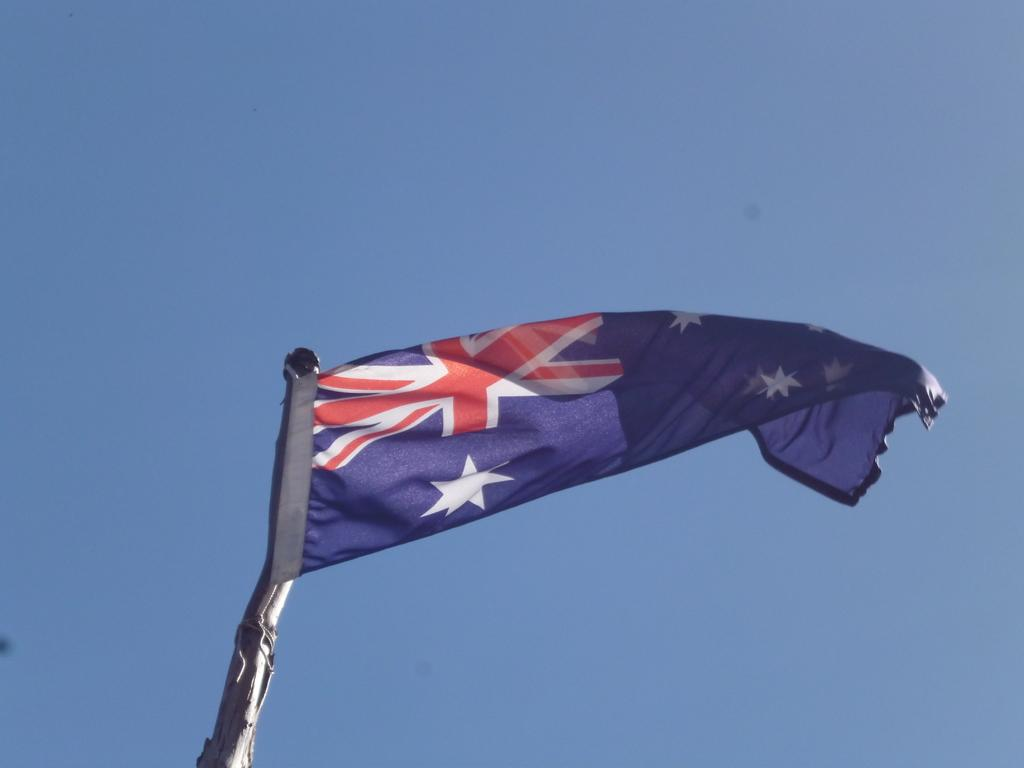What can be seen in the image? There is a flag in the image. What is visible in the background of the image? There is sky visible in the background of the image. What type of poison is being used to promote the growth of the flag in the image? There is no mention of poison or growth in the image; it simply shows a flag and the sky. 